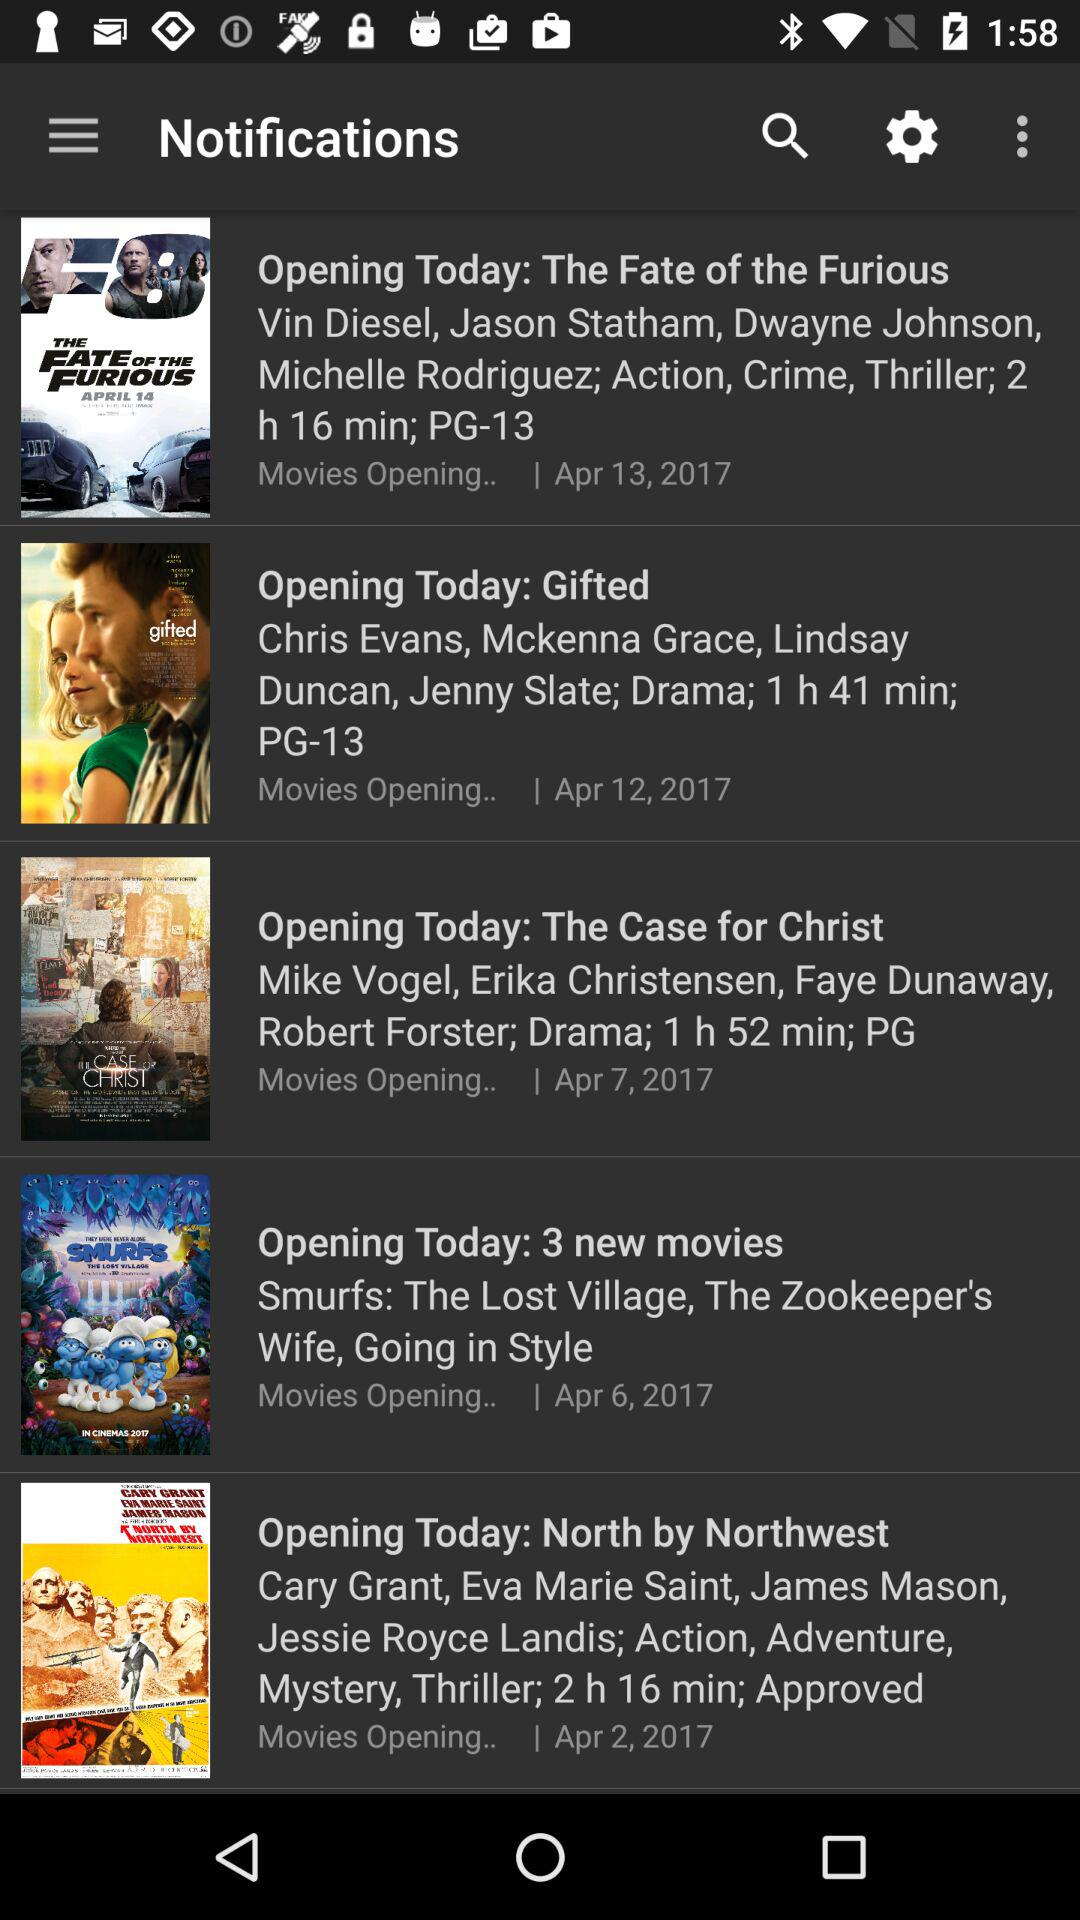What is the release date of "The Fate of the Furious"? The release date of "The Fate of the Furious" is April 13, 2017. 